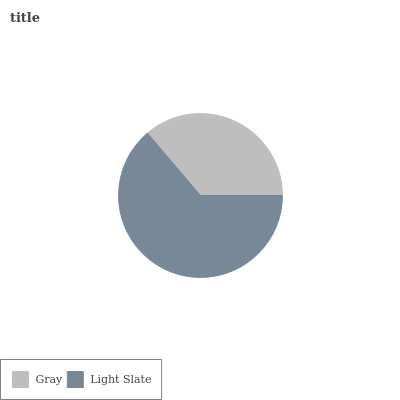Is Gray the minimum?
Answer yes or no. Yes. Is Light Slate the maximum?
Answer yes or no. Yes. Is Light Slate the minimum?
Answer yes or no. No. Is Light Slate greater than Gray?
Answer yes or no. Yes. Is Gray less than Light Slate?
Answer yes or no. Yes. Is Gray greater than Light Slate?
Answer yes or no. No. Is Light Slate less than Gray?
Answer yes or no. No. Is Light Slate the high median?
Answer yes or no. Yes. Is Gray the low median?
Answer yes or no. Yes. Is Gray the high median?
Answer yes or no. No. Is Light Slate the low median?
Answer yes or no. No. 